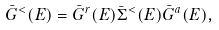<formula> <loc_0><loc_0><loc_500><loc_500>\bar { G } ^ { < } ( E ) = \bar { G } ^ { r } ( E ) \bar { \Sigma } ^ { < } ( E ) \bar { G } ^ { a } ( E ) ,</formula> 